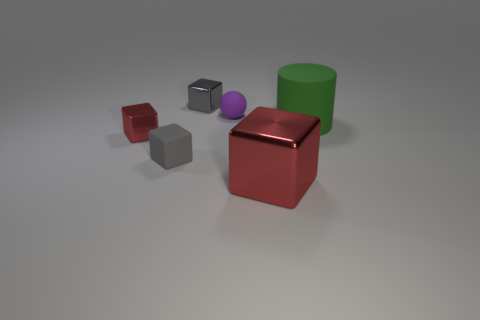The other block that is the same color as the big metallic block is what size?
Ensure brevity in your answer.  Small. Is the rubber ball the same color as the matte cylinder?
Offer a very short reply. No. There is a big metal object that is on the right side of the tiny purple thing; is it the same shape as the big green object?
Your response must be concise. No. How many green rubber objects are the same size as the rubber block?
Provide a succinct answer. 0. What shape is the thing that is the same color as the rubber block?
Provide a short and direct response. Cube. Is there a red object that is right of the red cube that is in front of the tiny gray rubber block?
Ensure brevity in your answer.  No. How many things are either metallic things in front of the green rubber object or small spheres?
Ensure brevity in your answer.  3. What number of red shiny things are there?
Offer a very short reply. 2. There is a large green thing that is made of the same material as the small purple object; what is its shape?
Ensure brevity in your answer.  Cylinder. There is a red shiny block behind the red metal block in front of the matte cube; what size is it?
Your response must be concise. Small. 